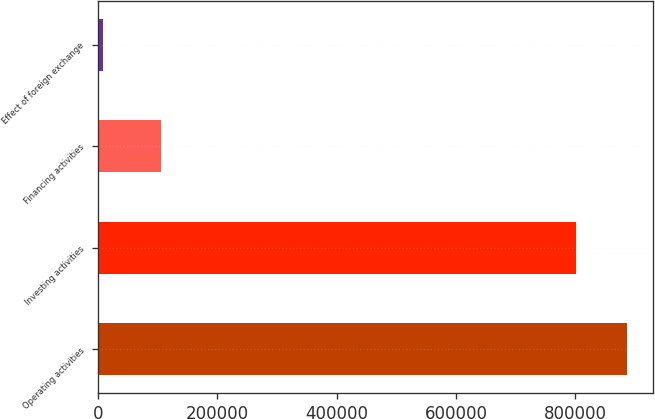Convert chart. <chart><loc_0><loc_0><loc_500><loc_500><bar_chart><fcel>Operating activities<fcel>Investing activities<fcel>Financing activities<fcel>Effect of foreign exchange<nl><fcel>886401<fcel>801343<fcel>106507<fcel>8603<nl></chart> 